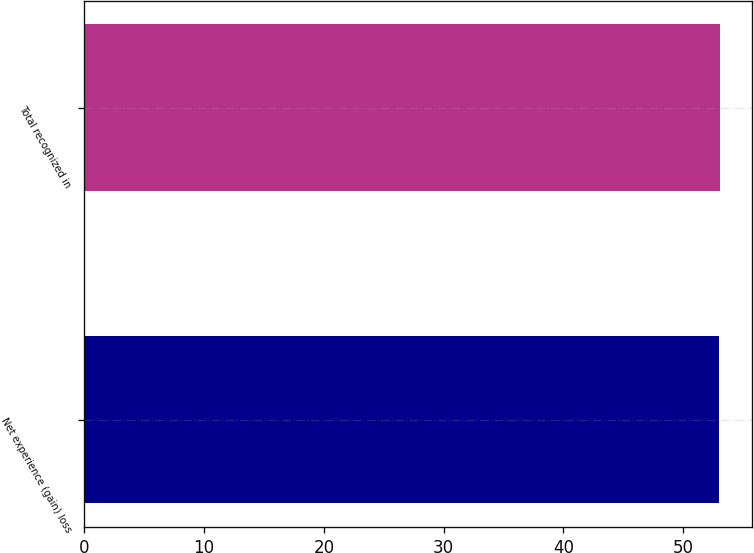Convert chart. <chart><loc_0><loc_0><loc_500><loc_500><bar_chart><fcel>Net experience (gain) loss<fcel>Total recognized in<nl><fcel>53<fcel>53.1<nl></chart> 